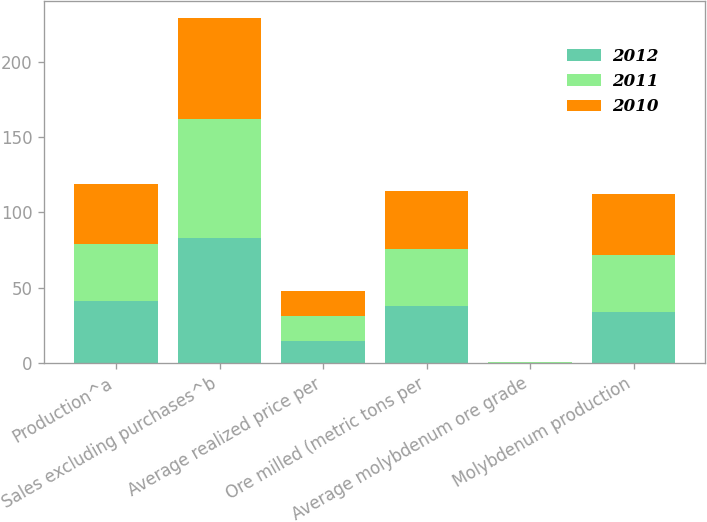<chart> <loc_0><loc_0><loc_500><loc_500><stacked_bar_chart><ecel><fcel>Production^a<fcel>Sales excluding purchases^b<fcel>Average realized price per<fcel>Ore milled (metric tons per<fcel>Average molybdenum ore grade<fcel>Molybdenum production<nl><fcel>2012<fcel>41<fcel>83<fcel>14.26<fcel>38<fcel>0.23<fcel>34<nl><fcel>2011<fcel>38<fcel>79<fcel>16.98<fcel>38<fcel>0.24<fcel>38<nl><fcel>2010<fcel>40<fcel>67<fcel>16.47<fcel>38<fcel>0.25<fcel>40<nl></chart> 